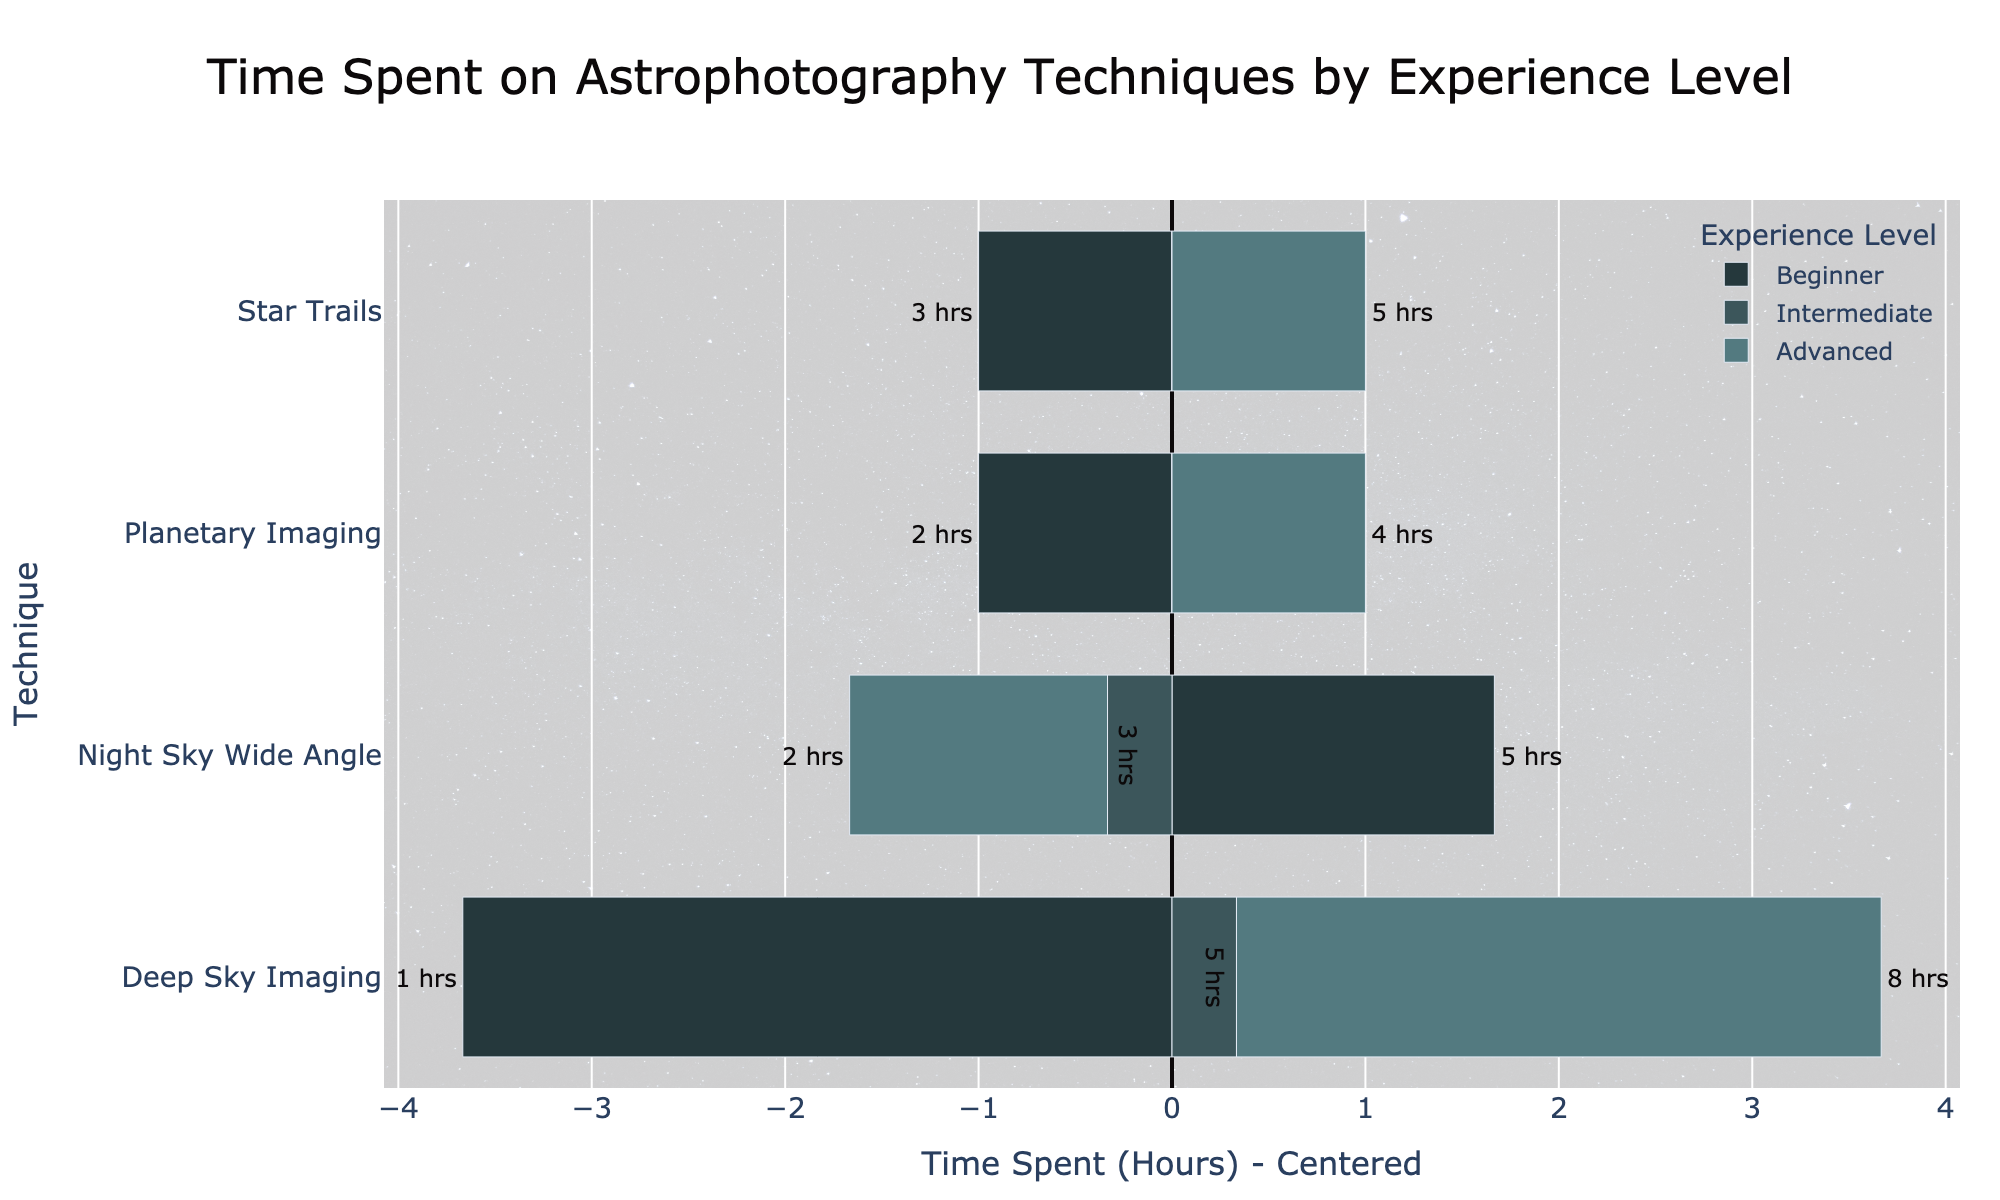What technique do advanced photographers spend the most time on? The figure shows a diverging bar chart with the time spent on each technique by different experience levels. For advanced photographers, the bar with the greatest positive deviation is for Deep Sky Imaging.
Answer: Deep Sky Imaging Which experience level spends the most time on Star Trails? The diverging bars for Star Trails indicate the relative time spent by each experience level. Advanced photographers have the highest positive bar for Star Trails.
Answer: Advanced What is the difference in time spent on Planetary Imaging between beginners and advanced photographers? Beginners spend 2 hours, and advanced photographers spend 4 hours on Planetary Imaging. The difference is calculated as 4 - 2.
Answer: 2 hours How does the time spent by intermediate photographers on Deep Sky Imaging compare to beginners? Intermediate photographers spend 5 hours, while beginners spend 1 hour on Deep Sky Imaging. 5 is greater than 1.
Answer: Intermediate spends more time Which technique shows the greatest variation in time spent between beginners and advanced photographers? By looking at the length of bars, Deep Sky Imaging has the largest difference in the lengths of the diverging bars between beginners and advanced photographers.
Answer: Deep Sky Imaging Is the time spent on Night Sky Wide Angle more or less uniform across different experience levels? The time centered bars are closest in length for Night Sky Wide Angle compared to other techniques, indicating a more uniform distribution across experience levels.
Answer: More uniform What is the combined total time spent on Star Trails by beginners and intermediate photographers? Beginners spend 3 hours, and intermediate photographers spend 4 hours on Star Trails. The combined total is calculated as 3 + 4.
Answer: 7 hours How much more time does an intermediate photographer spend on Deep Sky Imaging compared to a beginner in percentage terms? Beginners spend 1 hour, and intermediate photographers spend 5 hours on Deep Sky Imaging. To find the percentage increase: ((5 - 1) / 1) * 100 = 400%.
Answer: 400% Which experience level spends the least time on Deep Sky Imaging, and how many hours do they spend? The bars indicate that beginners spend the least time on Deep Sky Imaging, with a time of 1 hour.
Answer: Beginners, 1 hour Considering all techniques, which experience level generally has the most balanced (centered around 0) time spent? The lengths of the bars for each technique should be closest to the center line (0) for the most balanced distribution. Intermediate photographers have the bars most centered around 0 across all techniques, suggesting a balanced time spent.
Answer: Intermediate 